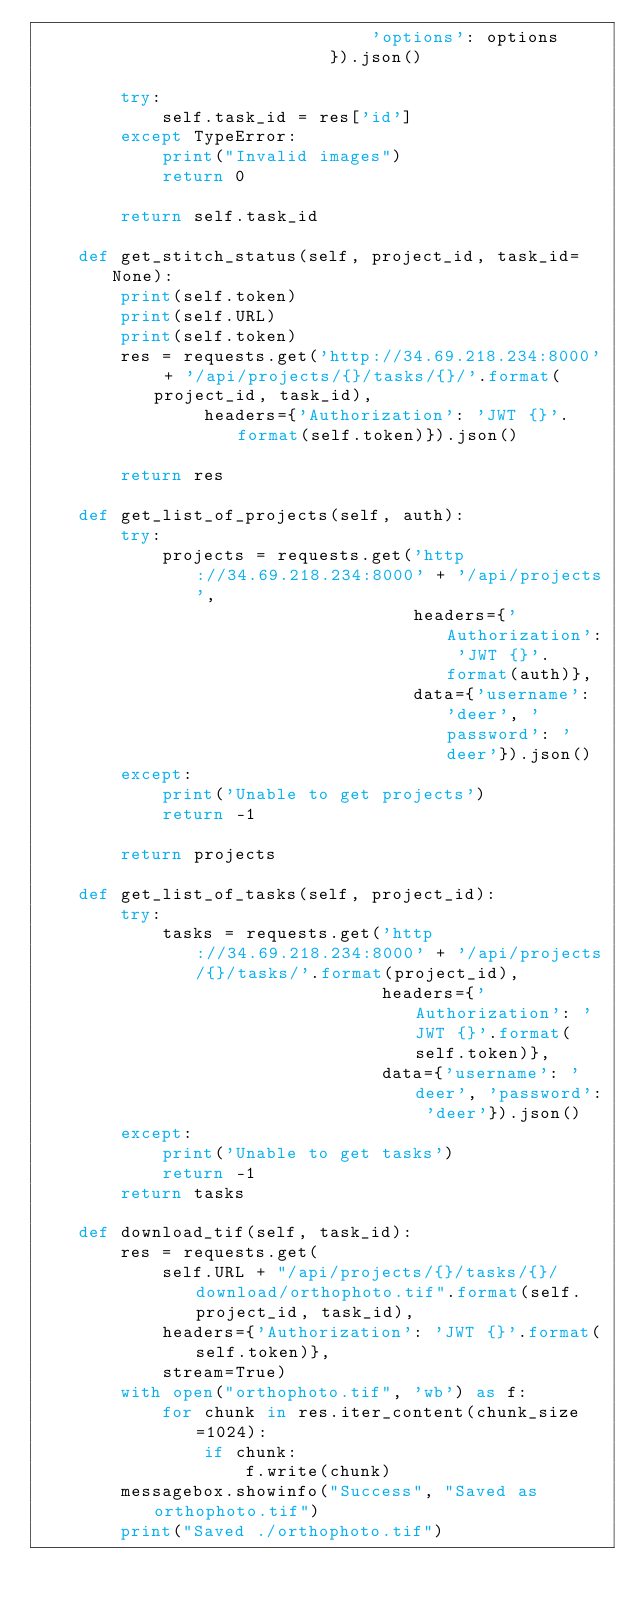Convert code to text. <code><loc_0><loc_0><loc_500><loc_500><_Python_>                                'options': options
                            }).json()

        try:
            self.task_id = res['id']
        except TypeError:
            print("Invalid images")
            return 0

        return self.task_id

    def get_stitch_status(self, project_id, task_id=None):
        print(self.token)
        print(self.URL)
        print(self.token)
        res = requests.get('http://34.69.218.234:8000' + '/api/projects/{}/tasks/{}/'.format(project_id, task_id),  
                headers={'Authorization': 'JWT {}'.format(self.token)}).json()

        return res

    def get_list_of_projects(self, auth):
        try:
            projects = requests.get('http://34.69.218.234:8000' + '/api/projects',
                                    headers={'Authorization': 'JWT {}'.format(auth)},
                                    data={'username': 'deer', 'password': 'deer'}).json()
        except:
            print('Unable to get projects')
            return -1

        return projects

    def get_list_of_tasks(self, project_id):
        try:
            tasks = requests.get('http://34.69.218.234:8000' + '/api/projects/{}/tasks/'.format(project_id),
                                 headers={'Authorization': 'JWT {}'.format(self.token)},
                                 data={'username': 'deer', 'password': 'deer'}).json()
        except:
            print('Unable to get tasks')
            return -1
        return tasks

    def download_tif(self, task_id):
        res = requests.get(
            self.URL + "/api/projects/{}/tasks/{}/download/orthophoto.tif".format(self.project_id, task_id),
            headers={'Authorization': 'JWT {}'.format(self.token)},
            stream=True)
        with open("orthophoto.tif", 'wb') as f:
            for chunk in res.iter_content(chunk_size=1024):
                if chunk:
                    f.write(chunk)
        messagebox.showinfo("Success", "Saved as orthophoto.tif")
        print("Saved ./orthophoto.tif")</code> 